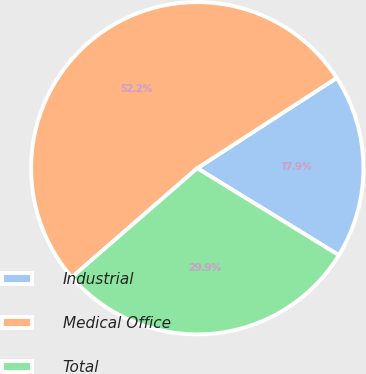Convert chart. <chart><loc_0><loc_0><loc_500><loc_500><pie_chart><fcel>Industrial<fcel>Medical Office<fcel>Total<nl><fcel>17.91%<fcel>52.24%<fcel>29.85%<nl></chart> 